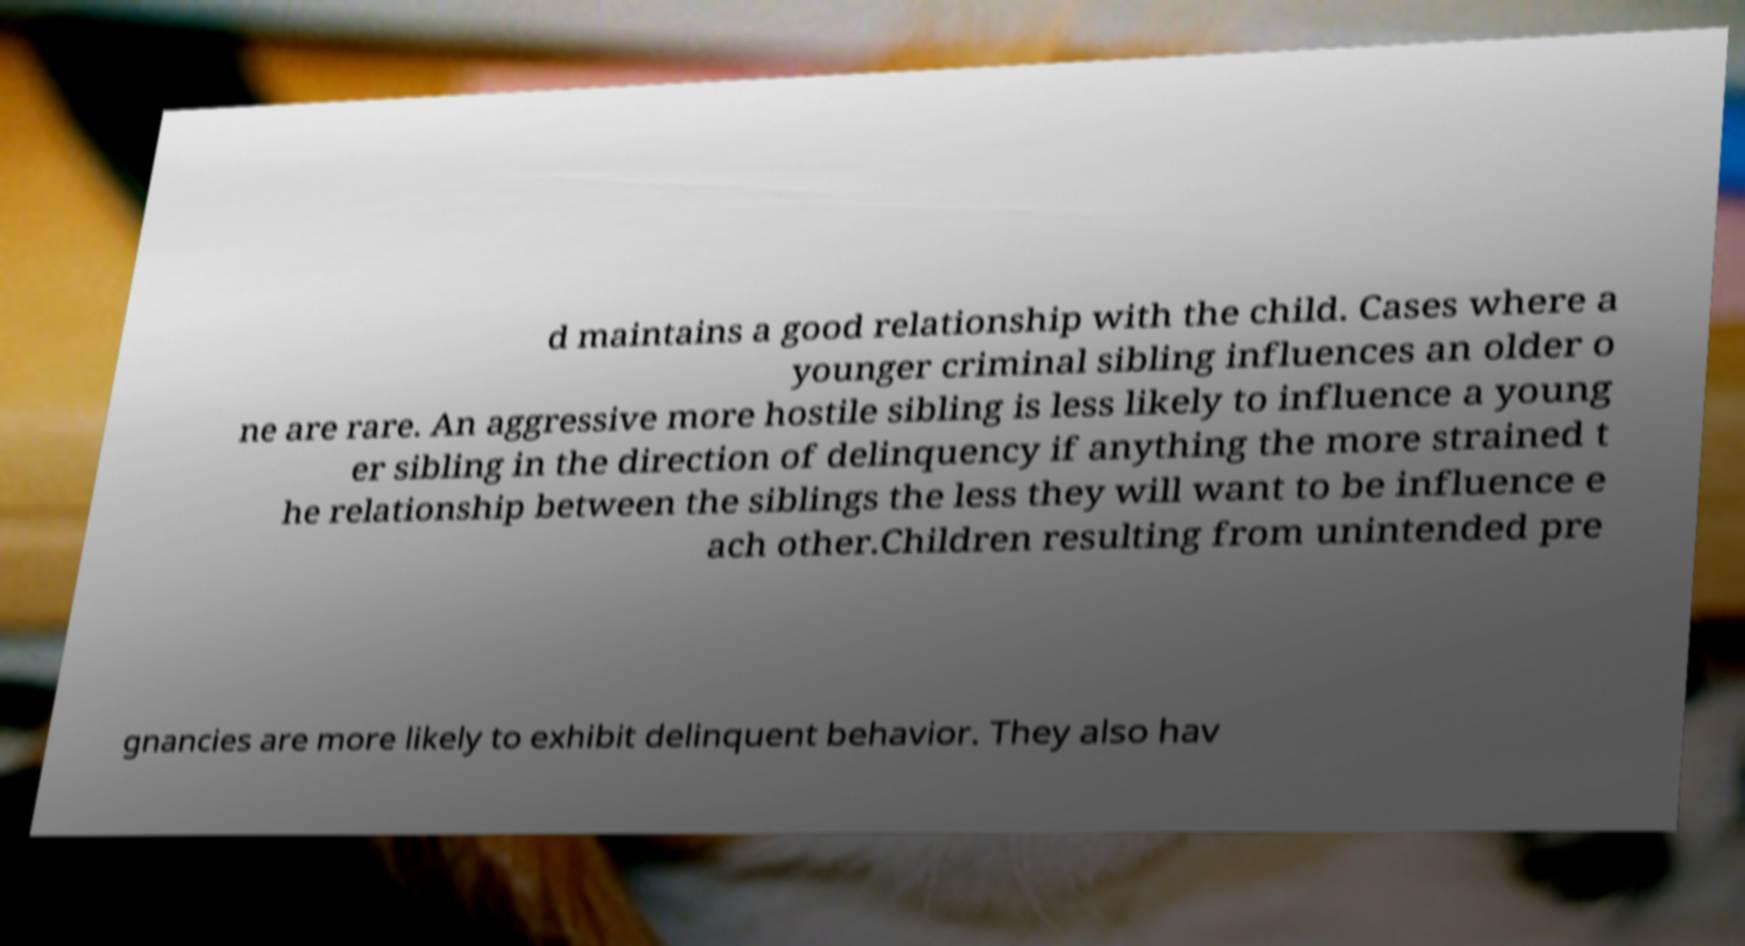Could you extract and type out the text from this image? d maintains a good relationship with the child. Cases where a younger criminal sibling influences an older o ne are rare. An aggressive more hostile sibling is less likely to influence a young er sibling in the direction of delinquency if anything the more strained t he relationship between the siblings the less they will want to be influence e ach other.Children resulting from unintended pre gnancies are more likely to exhibit delinquent behavior. They also hav 